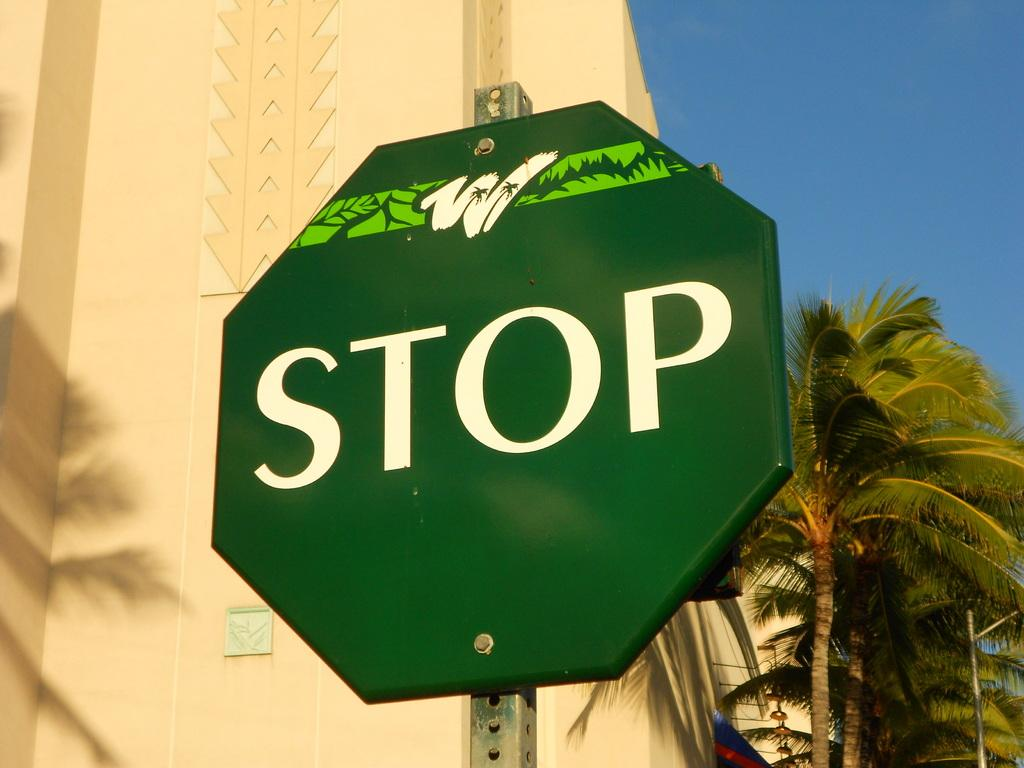<image>
Relay a brief, clear account of the picture shown. A green stop sign with the word stop in in white. 